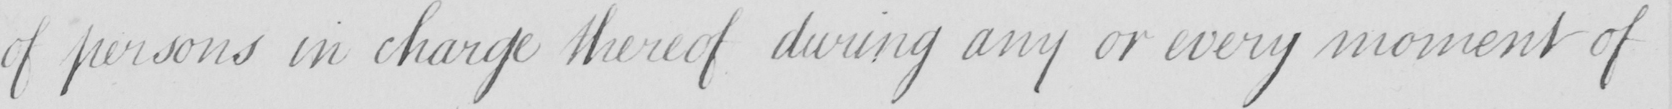Transcribe the text shown in this historical manuscript line. of persons in charge thereof during any or every moment of 